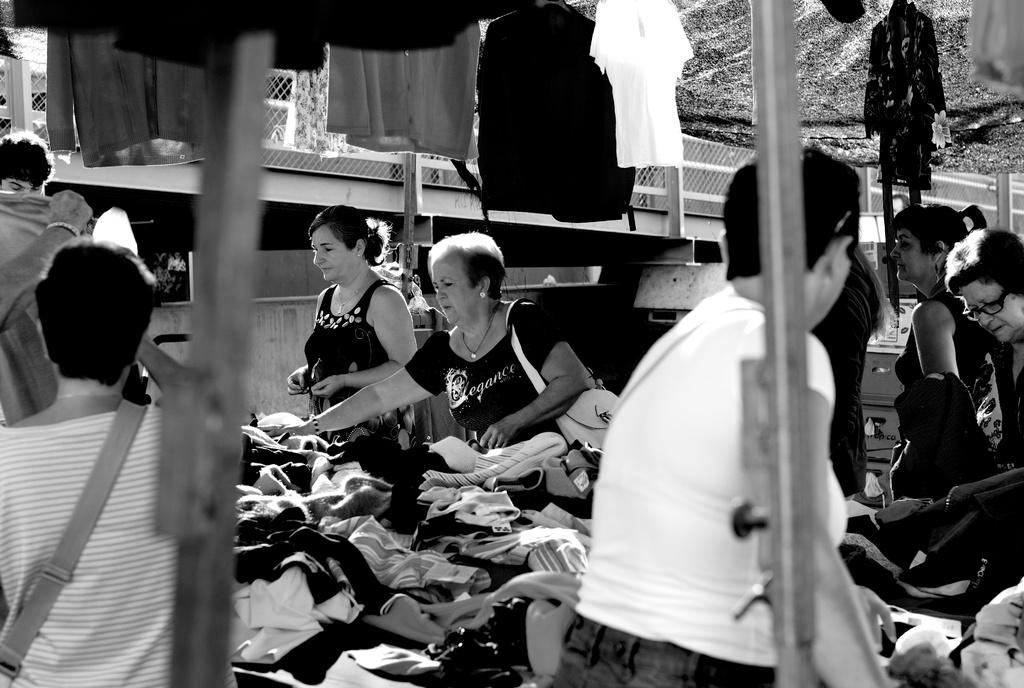Who or what can be seen in the image? There are people in the image. What is the color scheme of the image? The image is in black and white color. What else can be observed about the people in the image? Clothing is visible in the image. What type of stew is being prepared by the people in the image? There is no indication of any stew being prepared in the image; it only shows people and their clothing. What role does the brass play in the image? There is no brass present in the image. 